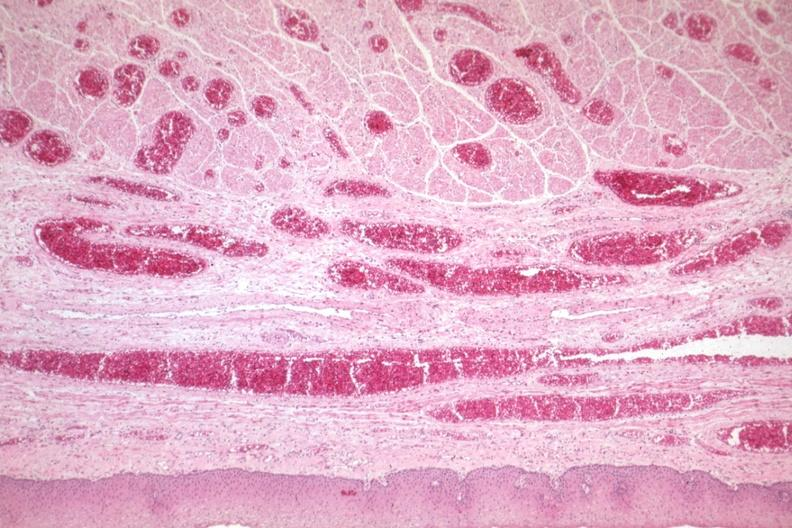s varices present?
Answer the question using a single word or phrase. Yes 